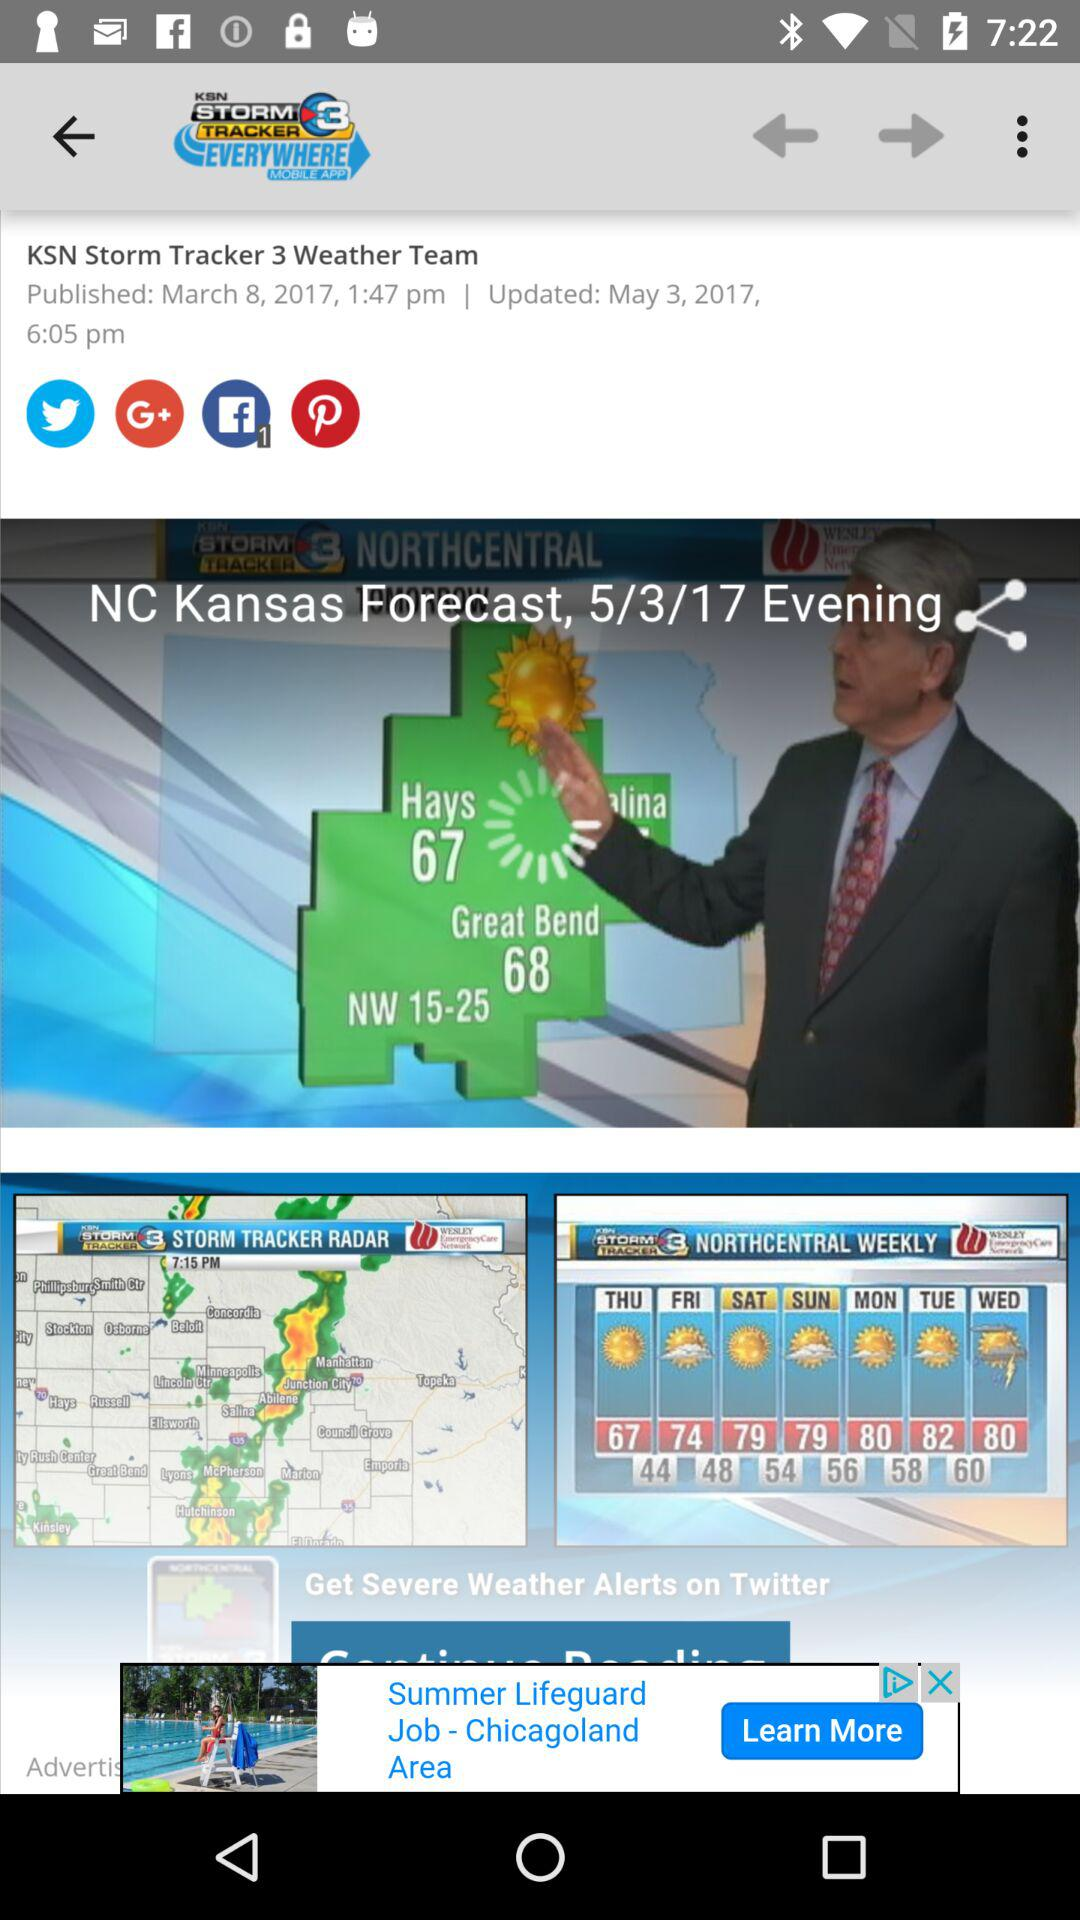When was the article updated? The article was updated on May 3, 2017 at 6:05 pm. 